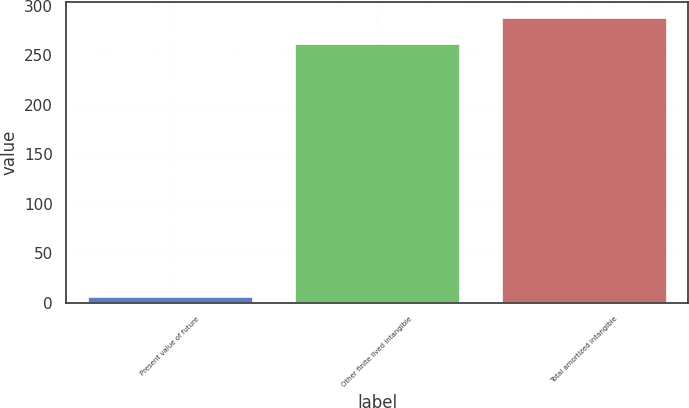<chart> <loc_0><loc_0><loc_500><loc_500><bar_chart><fcel>Present value of future<fcel>Other finite lived intangible<fcel>Total amortized intangible<nl><fcel>6.7<fcel>262.9<fcel>289.19<nl></chart> 